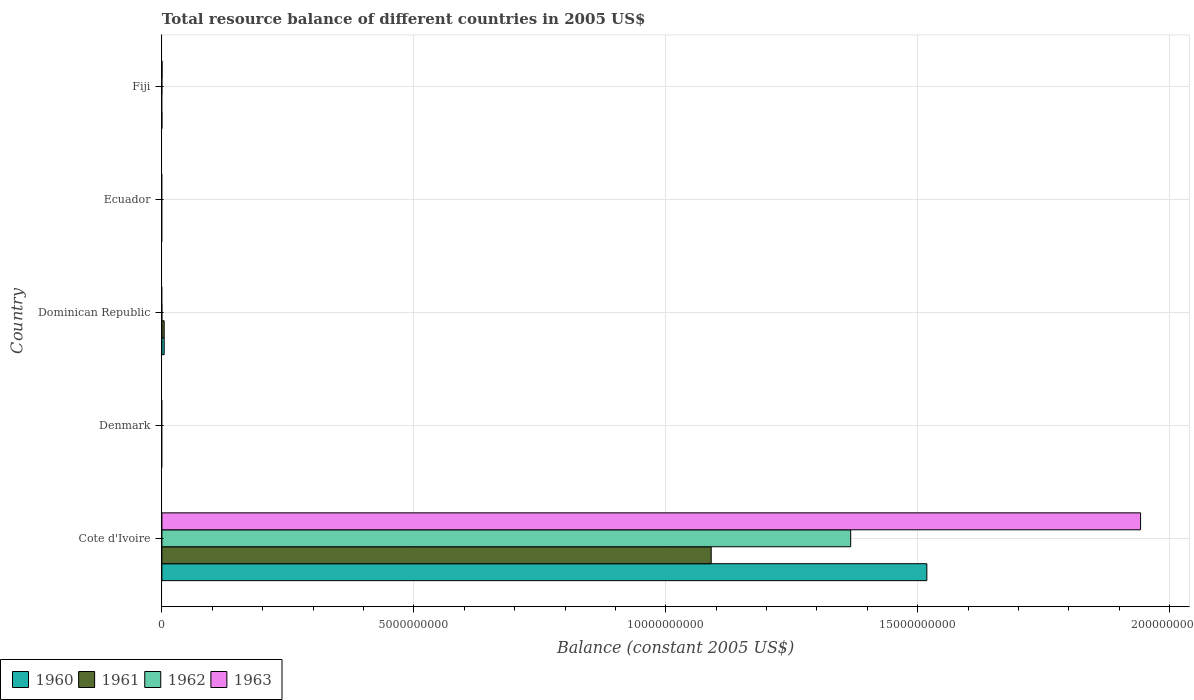How many different coloured bars are there?
Your response must be concise. 4. How many bars are there on the 5th tick from the bottom?
Make the answer very short. 1. What is the label of the 4th group of bars from the top?
Give a very brief answer. Denmark. In how many cases, is the number of bars for a given country not equal to the number of legend labels?
Keep it short and to the point. 4. Across all countries, what is the maximum total resource balance in 1963?
Offer a very short reply. 1.94e+1. Across all countries, what is the minimum total resource balance in 1961?
Ensure brevity in your answer.  0. In which country was the total resource balance in 1963 maximum?
Keep it short and to the point. Cote d'Ivoire. What is the total total resource balance in 1962 in the graph?
Keep it short and to the point. 1.37e+1. What is the difference between the total resource balance in 1960 in Cote d'Ivoire and that in Dominican Republic?
Provide a short and direct response. 1.51e+1. What is the difference between the total resource balance in 1961 in Dominican Republic and the total resource balance in 1963 in Fiji?
Your answer should be very brief. 4.27e+07. What is the average total resource balance in 1963 per country?
Ensure brevity in your answer.  3.88e+09. What is the difference between the total resource balance in 1962 and total resource balance in 1961 in Cote d'Ivoire?
Your answer should be very brief. 2.77e+09. In how many countries, is the total resource balance in 1962 greater than 17000000000 US$?
Keep it short and to the point. 0. What is the ratio of the total resource balance in 1961 in Cote d'Ivoire to that in Dominican Republic?
Keep it short and to the point. 241.17. Is the total resource balance in 1960 in Cote d'Ivoire less than that in Dominican Republic?
Offer a terse response. No. What is the difference between the highest and the lowest total resource balance in 1962?
Your answer should be compact. 1.37e+1. In how many countries, is the total resource balance in 1963 greater than the average total resource balance in 1963 taken over all countries?
Give a very brief answer. 1. Is the sum of the total resource balance in 1960 in Cote d'Ivoire and Dominican Republic greater than the maximum total resource balance in 1961 across all countries?
Make the answer very short. Yes. Are all the bars in the graph horizontal?
Provide a succinct answer. Yes. How many countries are there in the graph?
Offer a very short reply. 5. What is the difference between two consecutive major ticks on the X-axis?
Your response must be concise. 5.00e+09. Where does the legend appear in the graph?
Your answer should be very brief. Bottom left. How many legend labels are there?
Give a very brief answer. 4. How are the legend labels stacked?
Your answer should be compact. Horizontal. What is the title of the graph?
Keep it short and to the point. Total resource balance of different countries in 2005 US$. Does "1974" appear as one of the legend labels in the graph?
Offer a terse response. No. What is the label or title of the X-axis?
Provide a short and direct response. Balance (constant 2005 US$). What is the label or title of the Y-axis?
Offer a terse response. Country. What is the Balance (constant 2005 US$) of 1960 in Cote d'Ivoire?
Your response must be concise. 1.52e+1. What is the Balance (constant 2005 US$) of 1961 in Cote d'Ivoire?
Offer a terse response. 1.09e+1. What is the Balance (constant 2005 US$) in 1962 in Cote d'Ivoire?
Keep it short and to the point. 1.37e+1. What is the Balance (constant 2005 US$) in 1963 in Cote d'Ivoire?
Keep it short and to the point. 1.94e+1. What is the Balance (constant 2005 US$) of 1960 in Denmark?
Ensure brevity in your answer.  0. What is the Balance (constant 2005 US$) of 1962 in Denmark?
Provide a short and direct response. 0. What is the Balance (constant 2005 US$) in 1960 in Dominican Republic?
Offer a terse response. 4.56e+07. What is the Balance (constant 2005 US$) in 1961 in Dominican Republic?
Your answer should be very brief. 4.52e+07. What is the Balance (constant 2005 US$) in 1962 in Dominican Republic?
Offer a very short reply. 0. What is the Balance (constant 2005 US$) of 1961 in Ecuador?
Keep it short and to the point. 0. What is the Balance (constant 2005 US$) in 1962 in Ecuador?
Keep it short and to the point. 0. What is the Balance (constant 2005 US$) in 1963 in Ecuador?
Offer a terse response. 0. What is the Balance (constant 2005 US$) in 1960 in Fiji?
Your response must be concise. 0. What is the Balance (constant 2005 US$) of 1961 in Fiji?
Offer a terse response. 0. What is the Balance (constant 2005 US$) of 1962 in Fiji?
Give a very brief answer. 0. What is the Balance (constant 2005 US$) in 1963 in Fiji?
Your response must be concise. 2.50e+06. Across all countries, what is the maximum Balance (constant 2005 US$) of 1960?
Offer a very short reply. 1.52e+1. Across all countries, what is the maximum Balance (constant 2005 US$) in 1961?
Provide a short and direct response. 1.09e+1. Across all countries, what is the maximum Balance (constant 2005 US$) of 1962?
Provide a succinct answer. 1.37e+1. Across all countries, what is the maximum Balance (constant 2005 US$) in 1963?
Your answer should be compact. 1.94e+1. What is the total Balance (constant 2005 US$) in 1960 in the graph?
Provide a succinct answer. 1.52e+1. What is the total Balance (constant 2005 US$) of 1961 in the graph?
Your answer should be very brief. 1.09e+1. What is the total Balance (constant 2005 US$) of 1962 in the graph?
Offer a terse response. 1.37e+1. What is the total Balance (constant 2005 US$) of 1963 in the graph?
Make the answer very short. 1.94e+1. What is the difference between the Balance (constant 2005 US$) of 1960 in Cote d'Ivoire and that in Dominican Republic?
Provide a succinct answer. 1.51e+1. What is the difference between the Balance (constant 2005 US$) of 1961 in Cote d'Ivoire and that in Dominican Republic?
Ensure brevity in your answer.  1.09e+1. What is the difference between the Balance (constant 2005 US$) in 1963 in Cote d'Ivoire and that in Fiji?
Provide a succinct answer. 1.94e+1. What is the difference between the Balance (constant 2005 US$) of 1960 in Cote d'Ivoire and the Balance (constant 2005 US$) of 1961 in Dominican Republic?
Provide a short and direct response. 1.51e+1. What is the difference between the Balance (constant 2005 US$) of 1960 in Cote d'Ivoire and the Balance (constant 2005 US$) of 1963 in Fiji?
Offer a very short reply. 1.52e+1. What is the difference between the Balance (constant 2005 US$) of 1961 in Cote d'Ivoire and the Balance (constant 2005 US$) of 1963 in Fiji?
Offer a very short reply. 1.09e+1. What is the difference between the Balance (constant 2005 US$) of 1962 in Cote d'Ivoire and the Balance (constant 2005 US$) of 1963 in Fiji?
Ensure brevity in your answer.  1.37e+1. What is the difference between the Balance (constant 2005 US$) in 1960 in Dominican Republic and the Balance (constant 2005 US$) in 1963 in Fiji?
Provide a succinct answer. 4.31e+07. What is the difference between the Balance (constant 2005 US$) of 1961 in Dominican Republic and the Balance (constant 2005 US$) of 1963 in Fiji?
Your answer should be compact. 4.27e+07. What is the average Balance (constant 2005 US$) in 1960 per country?
Provide a short and direct response. 3.05e+09. What is the average Balance (constant 2005 US$) of 1961 per country?
Your answer should be very brief. 2.19e+09. What is the average Balance (constant 2005 US$) of 1962 per country?
Ensure brevity in your answer.  2.73e+09. What is the average Balance (constant 2005 US$) of 1963 per country?
Give a very brief answer. 3.88e+09. What is the difference between the Balance (constant 2005 US$) in 1960 and Balance (constant 2005 US$) in 1961 in Cote d'Ivoire?
Your response must be concise. 4.28e+09. What is the difference between the Balance (constant 2005 US$) in 1960 and Balance (constant 2005 US$) in 1962 in Cote d'Ivoire?
Your response must be concise. 1.51e+09. What is the difference between the Balance (constant 2005 US$) of 1960 and Balance (constant 2005 US$) of 1963 in Cote d'Ivoire?
Make the answer very short. -4.24e+09. What is the difference between the Balance (constant 2005 US$) in 1961 and Balance (constant 2005 US$) in 1962 in Cote d'Ivoire?
Give a very brief answer. -2.77e+09. What is the difference between the Balance (constant 2005 US$) of 1961 and Balance (constant 2005 US$) of 1963 in Cote d'Ivoire?
Give a very brief answer. -8.52e+09. What is the difference between the Balance (constant 2005 US$) of 1962 and Balance (constant 2005 US$) of 1963 in Cote d'Ivoire?
Make the answer very short. -5.75e+09. What is the ratio of the Balance (constant 2005 US$) in 1960 in Cote d'Ivoire to that in Dominican Republic?
Offer a terse response. 332.91. What is the ratio of the Balance (constant 2005 US$) in 1961 in Cote d'Ivoire to that in Dominican Republic?
Make the answer very short. 241.17. What is the ratio of the Balance (constant 2005 US$) in 1963 in Cote d'Ivoire to that in Fiji?
Make the answer very short. 7768.74. What is the difference between the highest and the lowest Balance (constant 2005 US$) of 1960?
Provide a short and direct response. 1.52e+1. What is the difference between the highest and the lowest Balance (constant 2005 US$) in 1961?
Offer a terse response. 1.09e+1. What is the difference between the highest and the lowest Balance (constant 2005 US$) of 1962?
Your answer should be compact. 1.37e+1. What is the difference between the highest and the lowest Balance (constant 2005 US$) of 1963?
Offer a very short reply. 1.94e+1. 